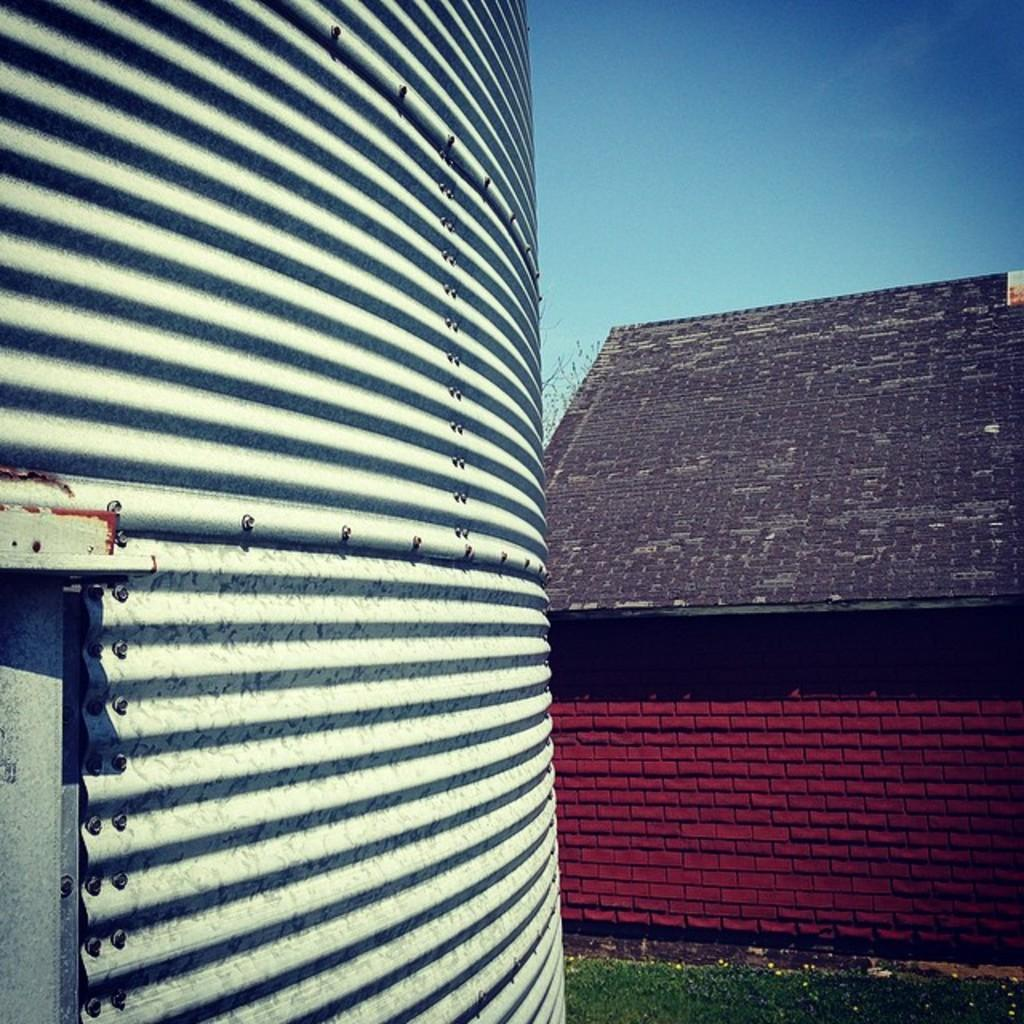What is located on the left side of the image? There is a surface on the left side of the image. What can be seen in the background of the image? There is a house and the sky visible in the background of the image. How many fangs can be seen in the image? There are no fangs present in the image. What time is displayed on the clocks in the image? There are no clocks present in the image. 